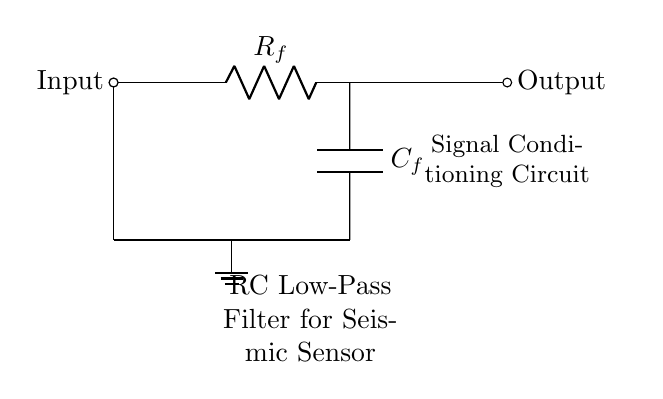What is the role of the resistor in this circuit? The resistor is used to limit the current flowing into the capacitor, affecting the charge and discharge rates, which is crucial for filtering high-frequency noise from the seismic sensor signal.
Answer: Current limiting What component is responsible for storing energy in this circuit? The capacitor stores energy in the electric field created between its plates, allowing it to filter out fast changes in the input signal, thus acting as a low-pass filter for the seismic signal.
Answer: Capacitor What type of filter does this circuit represent? The circuit is an RC low-pass filter designed to allow lower frequencies to pass while attenuating higher frequencies, which is useful for signal conditioning in seismic sensors.
Answer: Low-pass filter What is the output voltage behavior compared to the input voltage in this RC circuit at high frequencies? At high frequencies, the output voltage will be significantly lower than the input voltage due to the capacitor's reactance, which becomes very low, effectively shorting high-frequency signals to ground.
Answer: Lower What is the relevance of the ground connection in this circuit? The ground connection provides a reference point for the circuit voltages and helps stabilize the circuit operation. It ensures that the output signal is relative to a common voltage level, which is crucial for accurate signal processing in the sensor.
Answer: Reference point How does increasing the capacitor value affect the filter's frequency response? Increasing the capacitor value will lower the cutoff frequency of the filter, allowing more low-frequency signals to pass through while attenuating higher frequencies more effectively, which is beneficial in filtering seismic signals.
Answer: Lowers cutoff frequency 